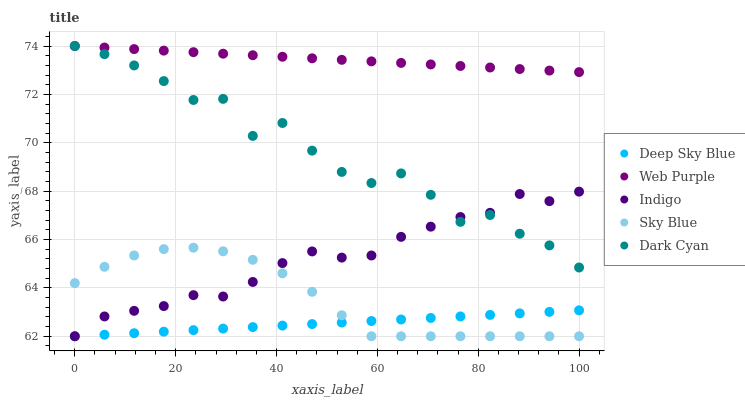Does Deep Sky Blue have the minimum area under the curve?
Answer yes or no. Yes. Does Web Purple have the maximum area under the curve?
Answer yes or no. Yes. Does Sky Blue have the minimum area under the curve?
Answer yes or no. No. Does Sky Blue have the maximum area under the curve?
Answer yes or no. No. Is Deep Sky Blue the smoothest?
Answer yes or no. Yes. Is Dark Cyan the roughest?
Answer yes or no. Yes. Is Sky Blue the smoothest?
Answer yes or no. No. Is Sky Blue the roughest?
Answer yes or no. No. Does Sky Blue have the lowest value?
Answer yes or no. Yes. Does Web Purple have the lowest value?
Answer yes or no. No. Does Web Purple have the highest value?
Answer yes or no. Yes. Does Sky Blue have the highest value?
Answer yes or no. No. Is Deep Sky Blue less than Web Purple?
Answer yes or no. Yes. Is Dark Cyan greater than Sky Blue?
Answer yes or no. Yes. Does Deep Sky Blue intersect Sky Blue?
Answer yes or no. Yes. Is Deep Sky Blue less than Sky Blue?
Answer yes or no. No. Is Deep Sky Blue greater than Sky Blue?
Answer yes or no. No. Does Deep Sky Blue intersect Web Purple?
Answer yes or no. No. 